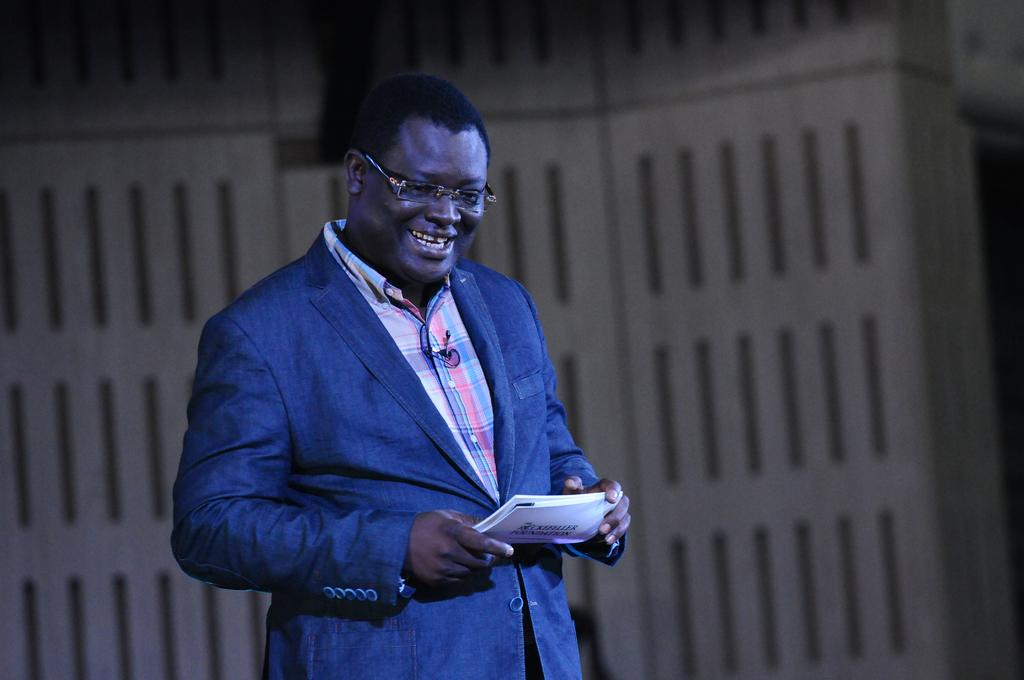Who is present in the image? There is a man in the image. What is the man holding in the image? The man is holding a paper. What can be seen in the background of the image? There is a white object in the image that looks like a wall. What type of gate is visible in the image? There is no gate present in the image. What frame is the man standing in the image? The image does not depict a frame around the man. 